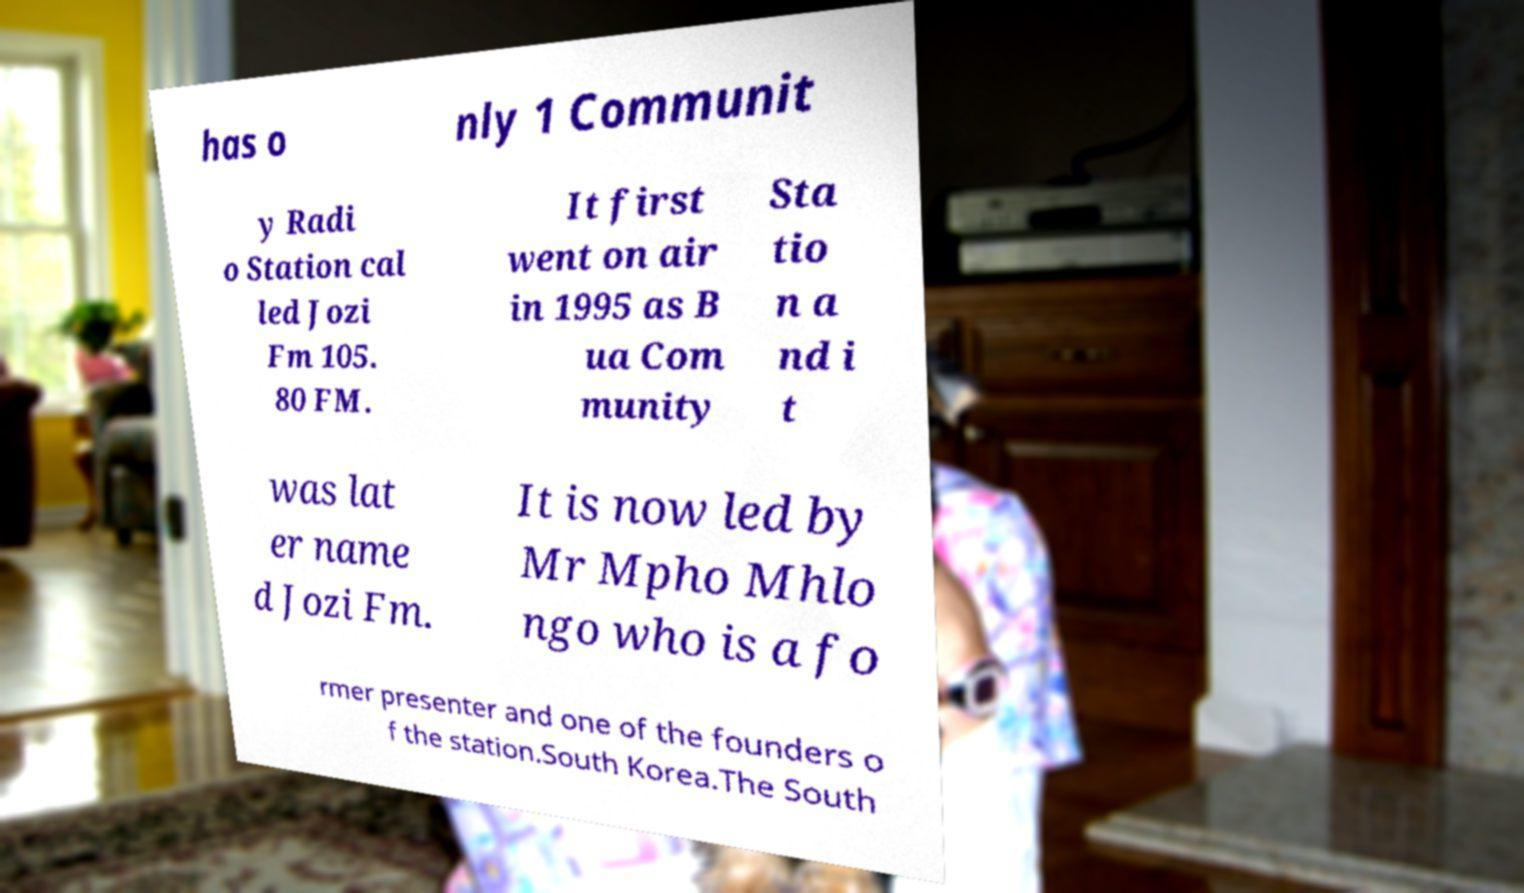Please read and relay the text visible in this image. What does it say? has o nly 1 Communit y Radi o Station cal led Jozi Fm 105. 80 FM. It first went on air in 1995 as B ua Com munity Sta tio n a nd i t was lat er name d Jozi Fm. It is now led by Mr Mpho Mhlo ngo who is a fo rmer presenter and one of the founders o f the station.South Korea.The South 